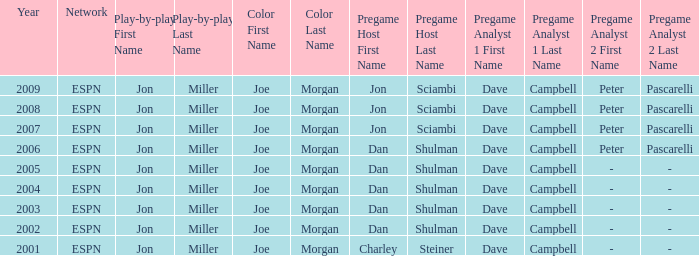How many networks are listed when the year is 2008? 1.0. 